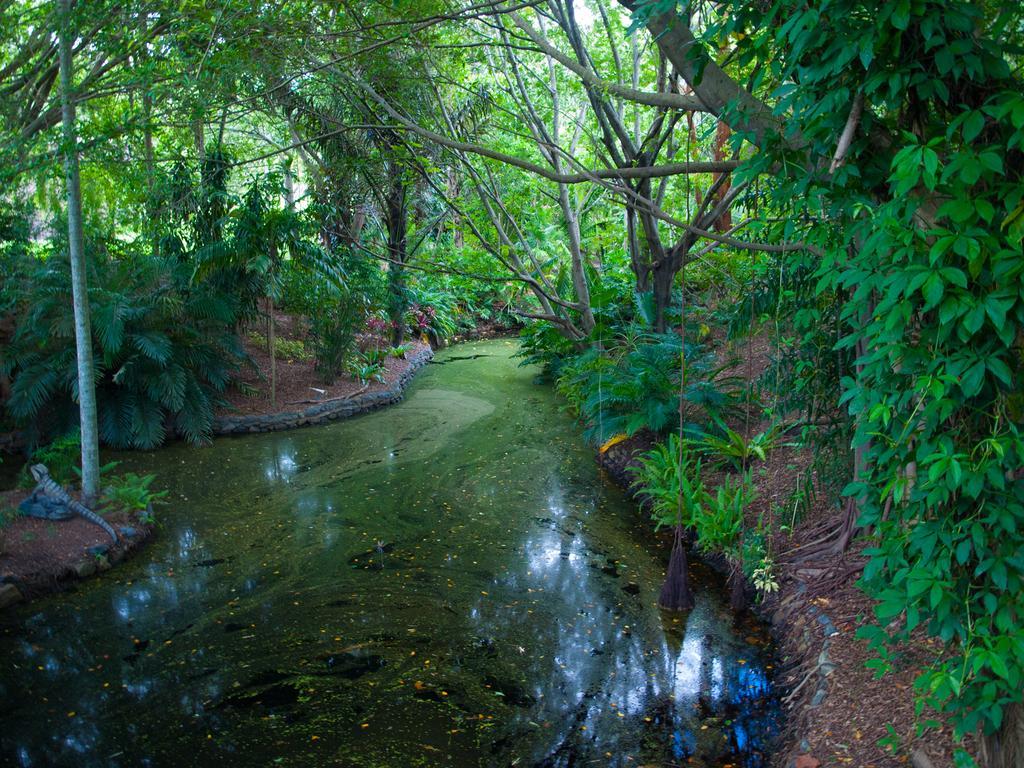Could you give a brief overview of what you see in this image? In this image we can see the trees, plants and also the water. We can also see a reptile on the stone. 